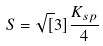Convert formula to latex. <formula><loc_0><loc_0><loc_500><loc_500>S = \sqrt { [ } 3 ] { \frac { K _ { s p } } { 4 } }</formula> 